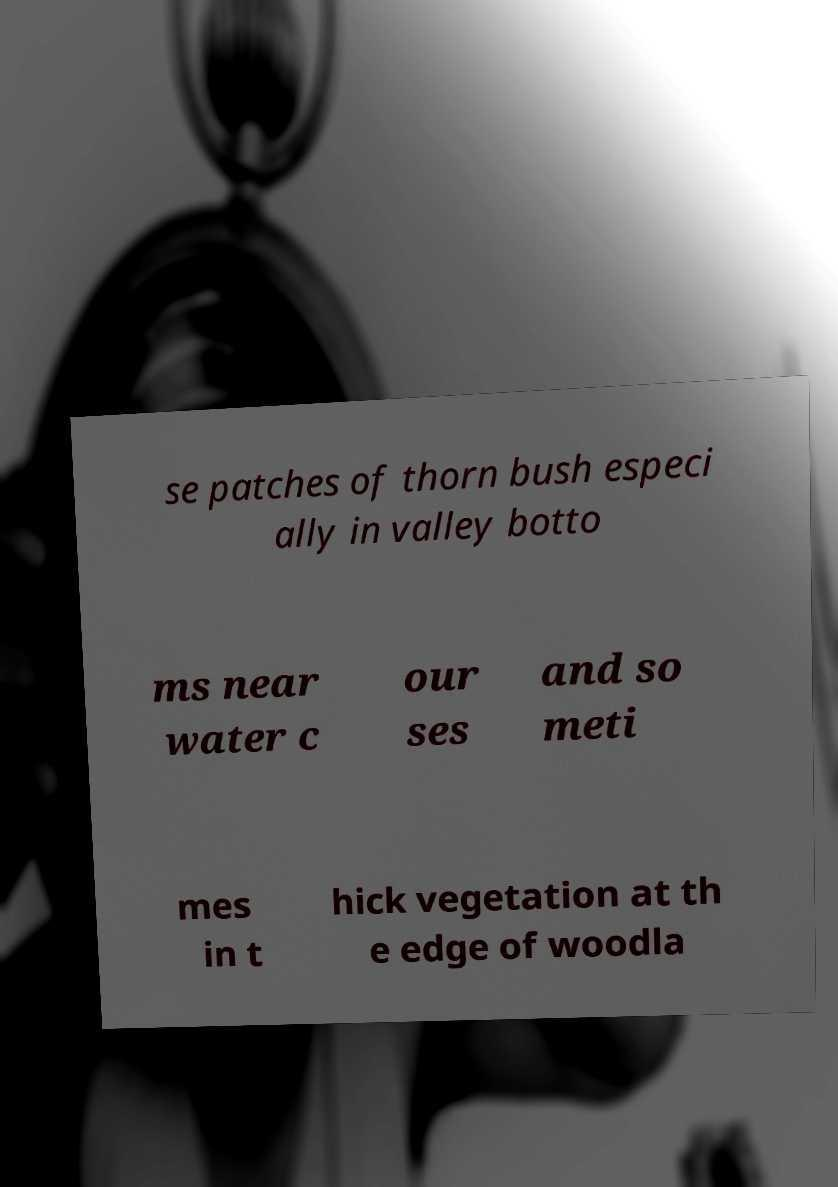Please read and relay the text visible in this image. What does it say? se patches of thorn bush especi ally in valley botto ms near water c our ses and so meti mes in t hick vegetation at th e edge of woodla 